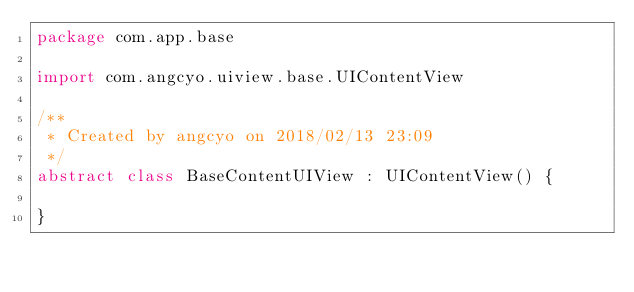<code> <loc_0><loc_0><loc_500><loc_500><_Kotlin_>package com.app.base

import com.angcyo.uiview.base.UIContentView

/**
 * Created by angcyo on 2018/02/13 23:09
 */
abstract class BaseContentUIView : UIContentView() {

}</code> 